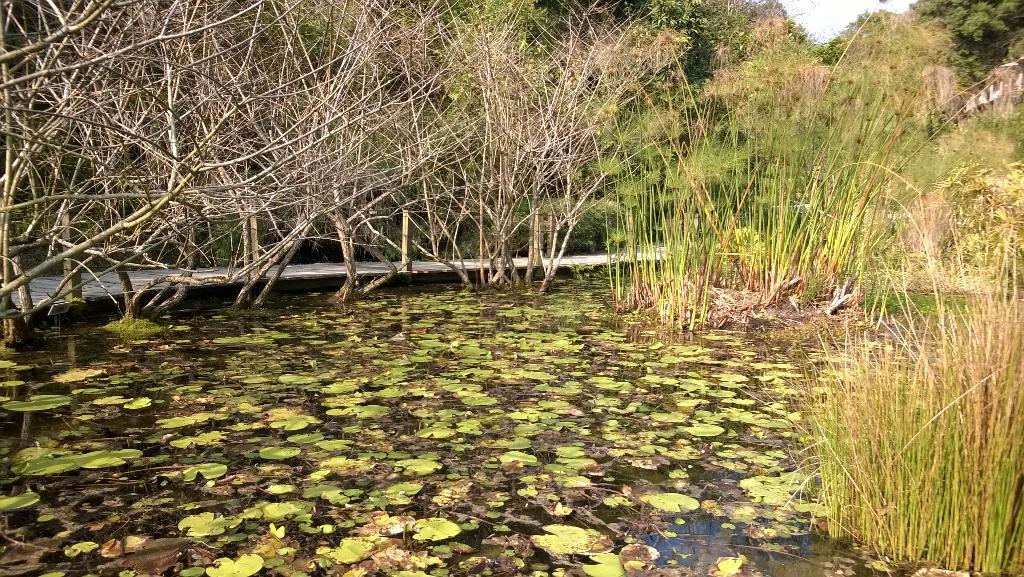What is the main element present in the image? There is water in the image. What types of plants can be seen in the water? There are aquatic plants in the water. What other type of vegetation is present in the water? There is grass in the water. What can be seen in the background of the image? There are trees in the background of the image. What is visible at the top of the image? The sky is visible at the top of the image. What type of powder is being used to create the weather effect in the image? There is no powder or weather effect present in the image; it features water with plants and trees in the background. 